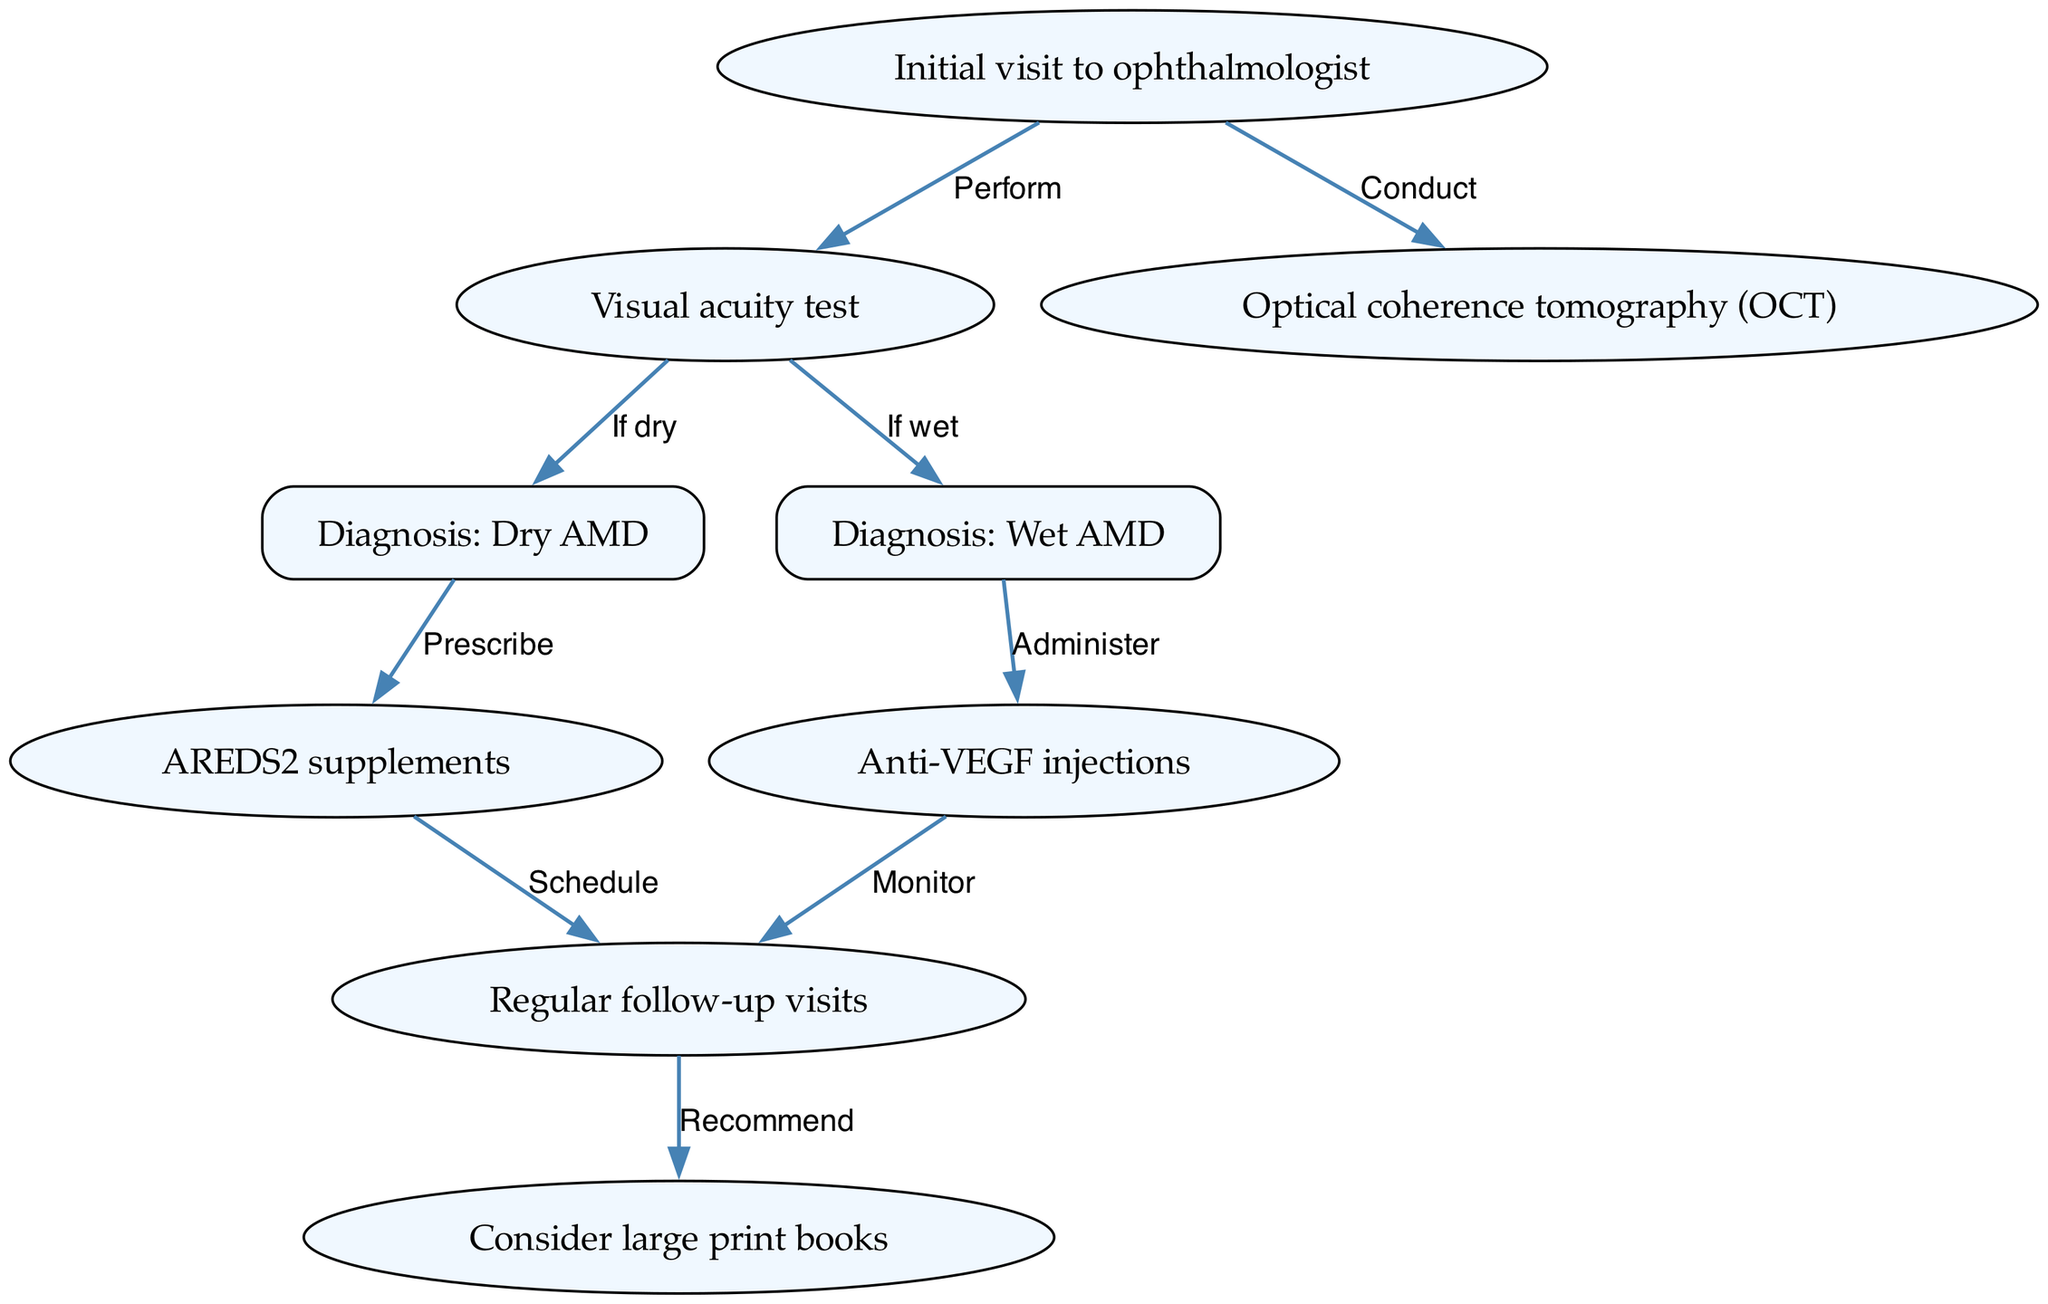What is the first step in the clinical pathway? The first step is the "Initial visit to ophthalmologist," indicated as the starting node in the diagram. This represents the beginning of the treatment pathway for age-related macular degeneration.
Answer: Initial visit to ophthalmologist How many nodes are there in the diagram? Counting the nodes listed in the data, there are a total of 9 nodes. Each represents a step or element in the clinical pathway.
Answer: 9 What is prescribed after a diagnosis of Dry AMD? Following the diagnosis of Dry AMD, the next step in the pathway is to "Prescribe AREDS2 supplements," as indicated by the edges in the diagram.
Answer: AREDS2 supplements What type of injections are administered for Wet AMD? The diagram shows that after the diagnosis of Wet AMD, "Anti-VEGF injections" are administered. This is a direct flow from the Wet AMD diagnosis node to the treatment node.
Answer: Anti-VEGF injections What is scheduled after prescribing AREDS2 supplements? The pathway indicates that after prescribing AREDS2 supplements, the subsequent action is to "Schedule regular follow-up visits," which is the next step in managing Dry AMD.
Answer: Schedule regular follow-up visits If the visual acuity test results indicate Wet AMD, what procedure follows? In the event that the visual acuity test results indicate Wet AMD, the diagram states that the next step would be to "Administer Anti-VEGF injections," which is essential for treating this type of AMD.
Answer: Administer Anti-VEGF injections How are follow-up visits related to recommendations for large print books? After regular follow-up visits are scheduled, the diagram indicates that one of the recommendations from these visits is to "Consider large print books," suggesting a direct relation between monitoring the disease and lifestyle adjustments.
Answer: Consider large print books What node indicates the diagnosis of Wet AMD? The node corresponding to the diagnosis of Wet AMD is labeled "Diagnosis: Wet AMD," which is clearly defined in the diagram as a crucial decision point in the pathway.
Answer: Diagnosis: Wet AMD What step follows the "Regular follow-up visits"? The diagram notes that following regular follow-up visits, the recommendation to "Consider large print books" is made, linking ongoing treatment and support for patients.
Answer: Consider large print books 